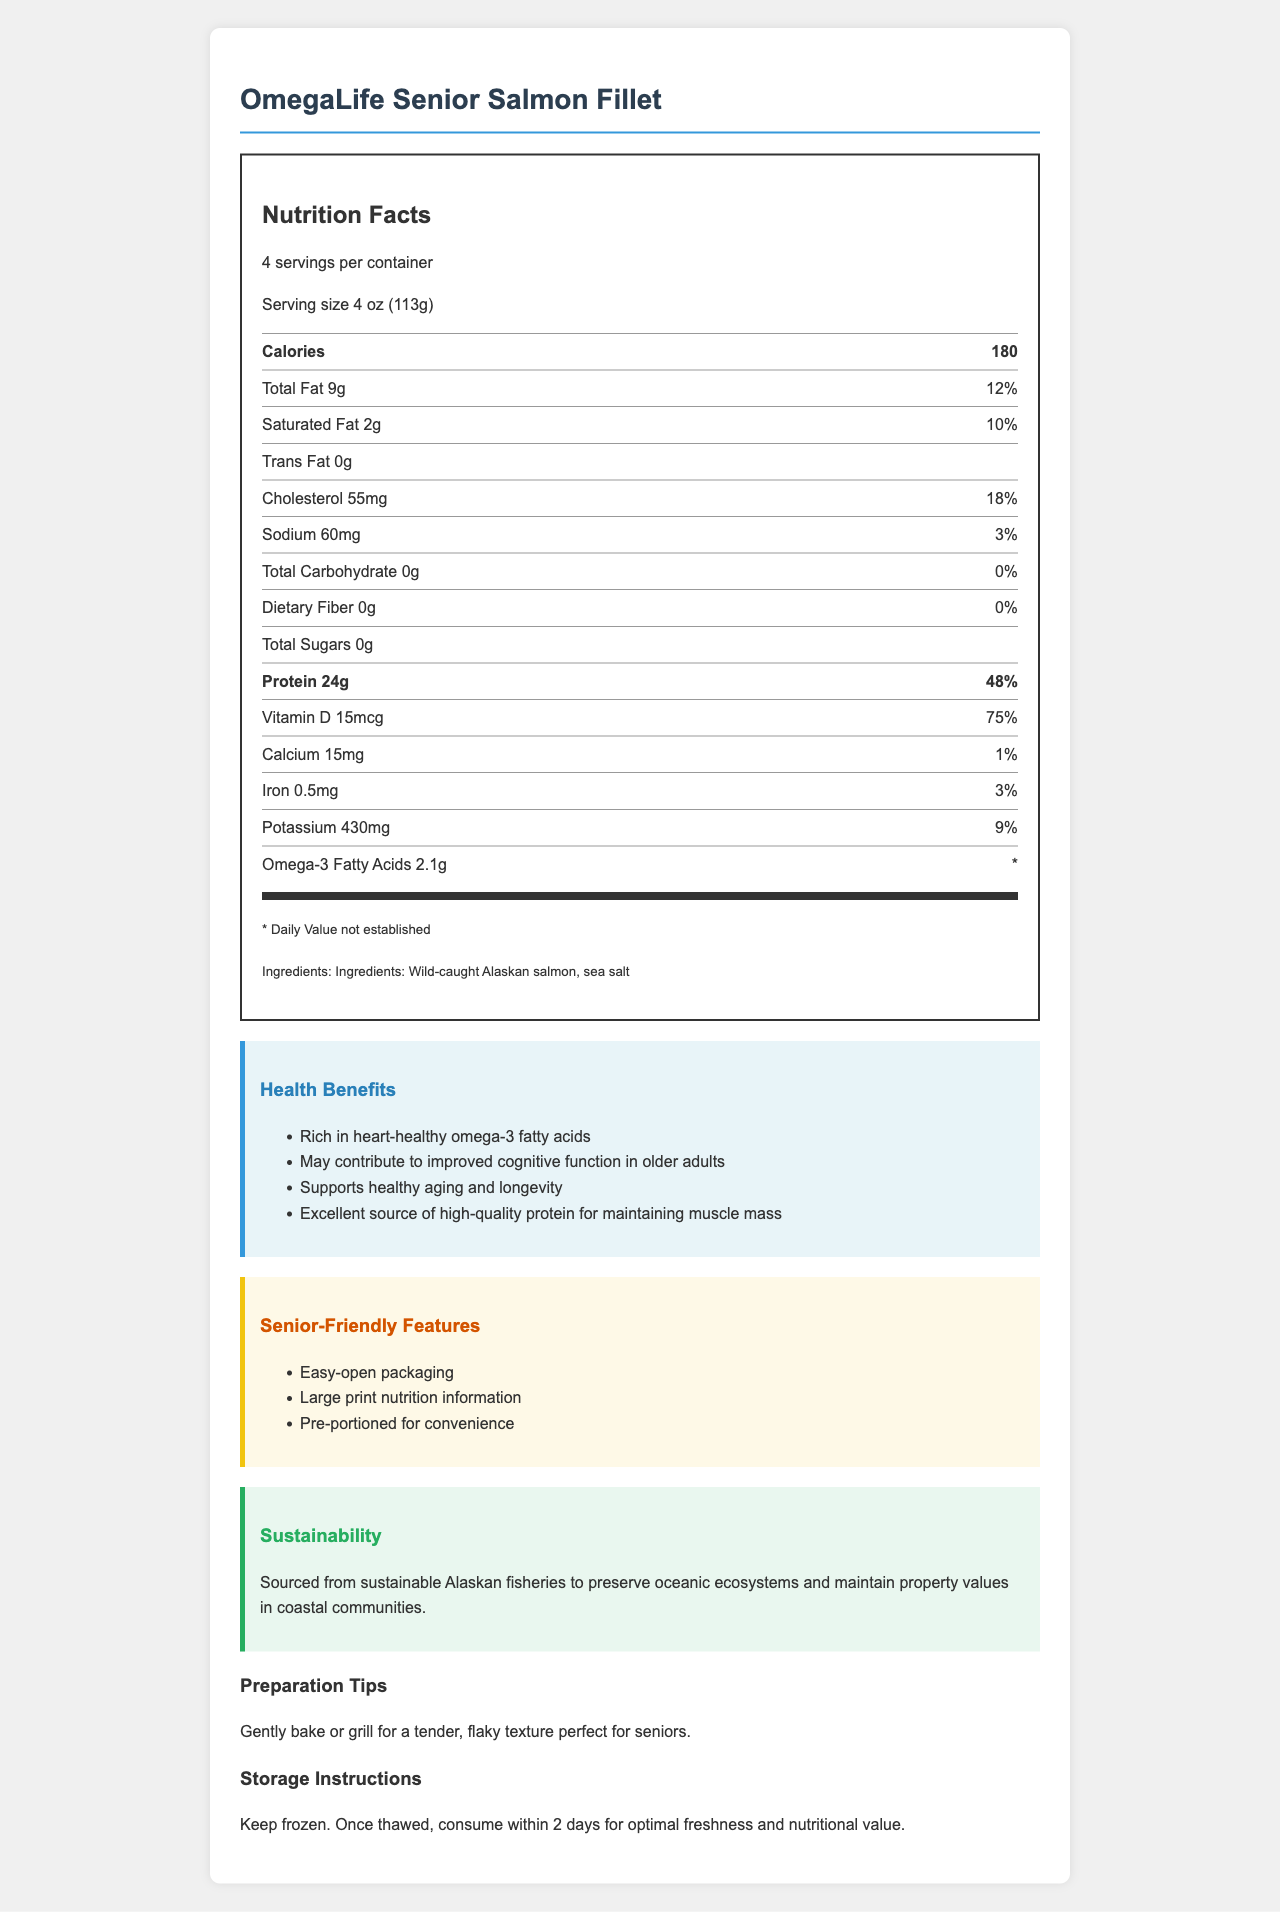what is the serving size? The serving size is stated at the beginning of the nutrition label section as "Serving size 4 oz (113g)".
Answer: 4 oz (113g) how many servings are in the container? The number of servings per container is mentioned right after the product name and the servings per container section.
Answer: 4 how much cholesterol is in one serving? The amount of cholesterol per serving is listed under the nutrition facts section.
Answer: 55mg what percentage of the daily value does the vitamin D content represent? The daily value percentage for vitamin D is shown alongside the amount as "Vitamin D 15mcg 75%".
Answer: 75% is there any dietary fiber in this product? The nutrition label specifies "Dietary Fiber 0g", which confirms there is no dietary fiber.
Answer: No which nutrient has the highest daily value percentage? A. Total Fat B. Protein C. Vitamin D D. Potassium Vitamin D has 75%, Total Fat has 12%, Potassium has 9%, and Protein has 48%. Therefore, Vitamin D, option C, has the highest daily value percentage.
Answer: B what are the health benefits mentioned for this product? A. Improves digestion B. Supports healthy aging C. Reduces blood sugar D. Enhances bone strength The health benefits section lists "Supports healthy aging and longevity" as one of the benefits.
Answer: B is this product high in protein? The label indicates that each serving contains 24g of protein, which is 48% of the daily value.
Answer: Yes summarize the main features of this product The product has a senior-friendly design with substantial health benefits, including support for longevity and cognitive function. It emphasizes sustainability efforts, convenient packaging, and preparation tips for seniors.
Answer: OmegaLife Senior Salmon Fillet is a heart-healthy, omega-3 rich fish product designed for seniors. The product offers an easy-open packaging, large print information, and is pre-portioned for convenience. It supports healthy aging, cognitive function, and maintains muscle mass. Sourced sustainably, it also contributes to preserving ocean ecosystems and coastal community property values. how many grams of omega-3 fatty acids does this product contain per serving? The amount of omega-3 fatty acids per serving is specified under the nutrition facts section.
Answer: 2.1g what is the recommended way to prepare this product? The preparation tips section advises consumers to bake or grill the product gently.
Answer: Gently bake or grill for a tender, flaky texture perfect for seniors. does this product help in maintaining muscle mass? One of the listed health claims is "Excellent source of high-quality protein for maintaining muscle mass."
Answer: Yes what is the source of the salmon used in this product? The ingredients section specifies that the salmon is wild-caught from Alaska.
Answer: Wild-caught Alaskan salmon what is the sustainability commitment of this product? The sustainability statement clearly mentions their commitment to sustainable sourcing to preserve ecosystems and maintain property values.
Answer: Sourced from sustainable Alaskan fisheries to preserve oceanic ecosystems and maintain property values in coastal communities. how many days can the product be consumed after being thawed? The storage instructions advise consuming the product within 2 days after thawing for optimal freshness and nutritional value.
Answer: Within 2 days what is the main ingredient of this product? According to the ingredients list provided in the nutrition facts, the main ingredient is wild-caught Alaskan salmon.
Answer: Wild-caught Alaskan salmon is this product low in sodium? The sodium content per serving is 60mg, which is only 3% of the daily value, indicating it is low in sodium.
Answer: Yes what is the percentage of daily value for calcium? The nutrition label indicates that calcium accounts for just 1% of the daily value.
Answer: 1% is the omega-3 fatty acid daily value established? The daily value for omega-3 fatty acids is marked with an asterisk (*) noting that the daily value is not established.
Answer: No how much potassium is in a serving of this product? The nutrition facts section lists potassium content as 430mg per serving.
Answer: 430mg 